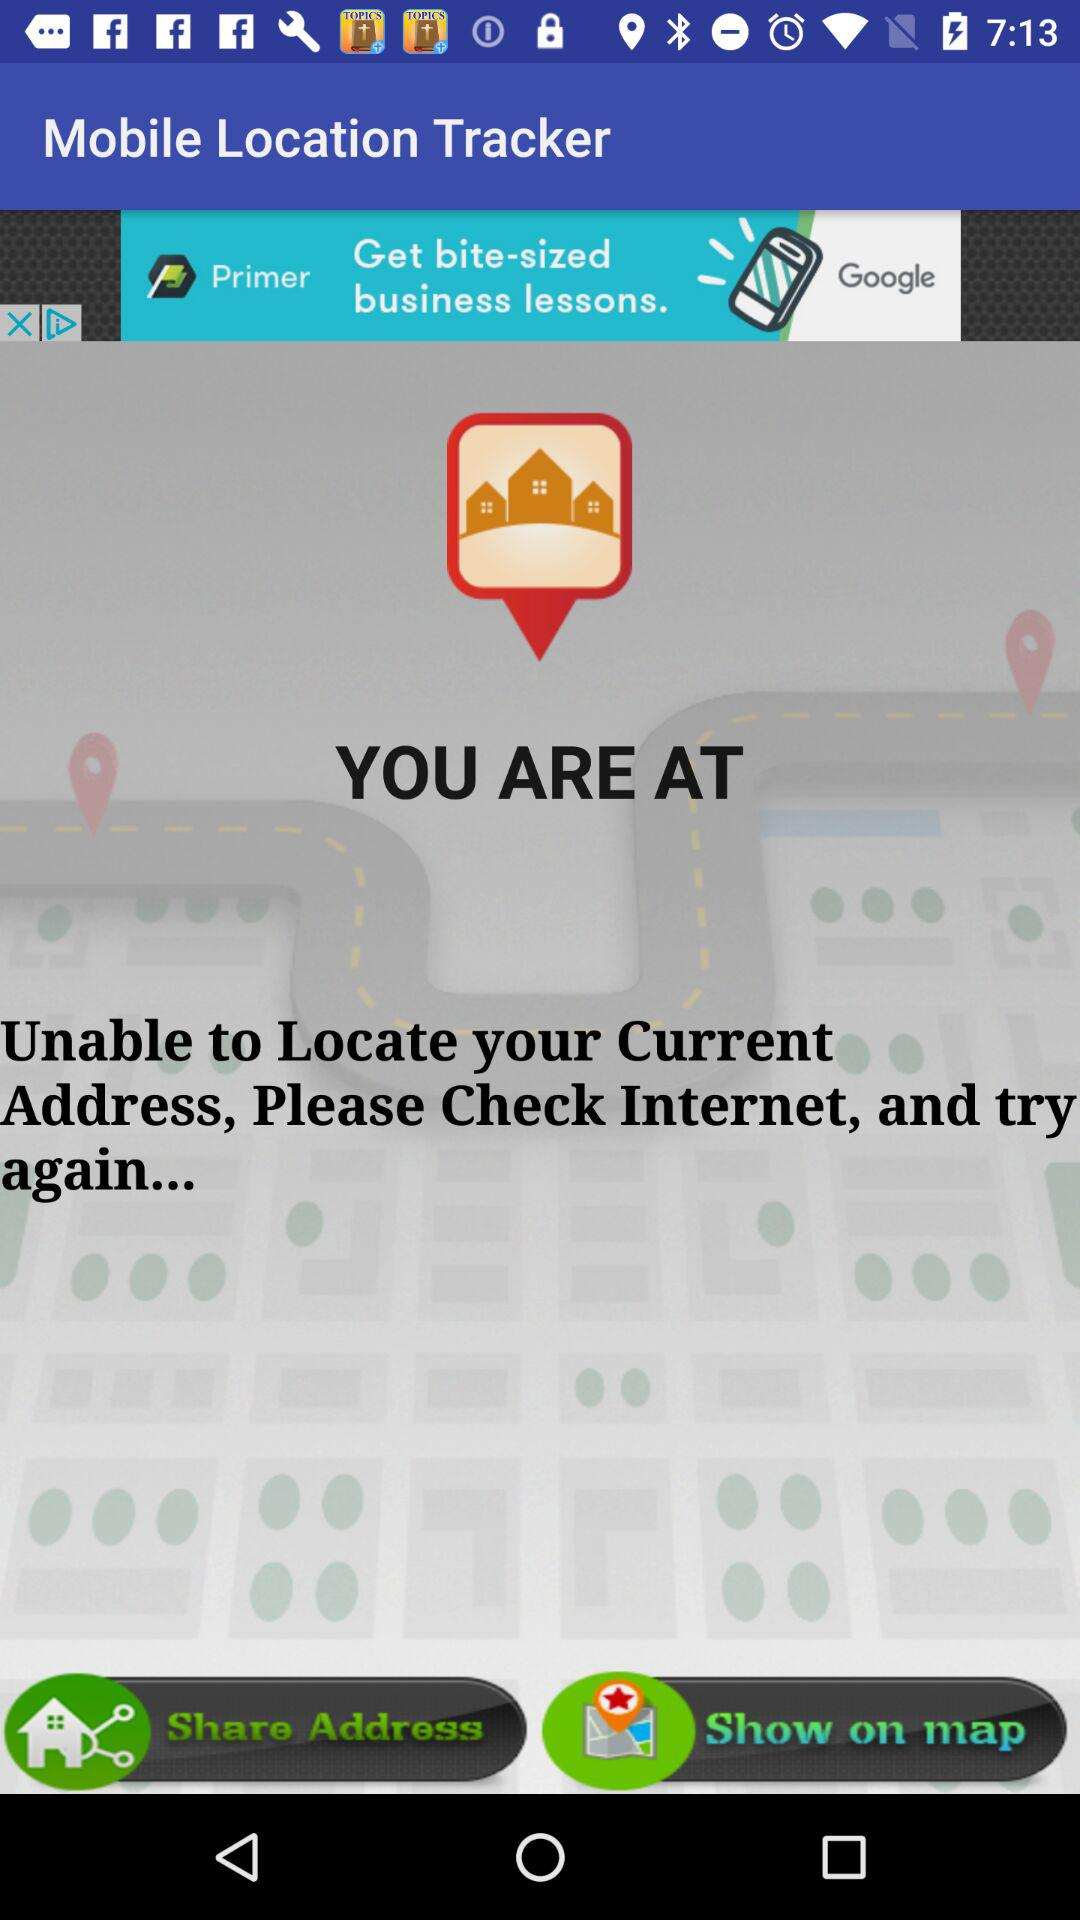What is the name of the application? The name of the application is "Mobile Location Tracker". 